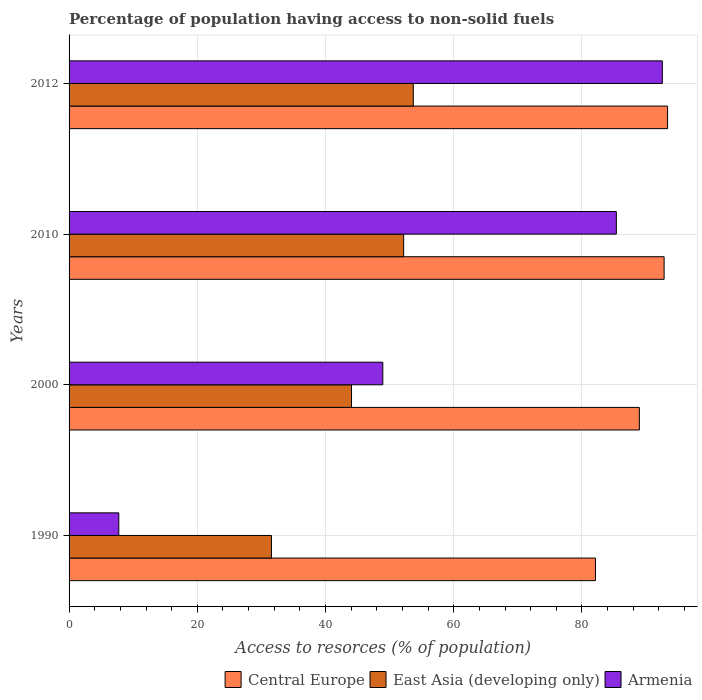Are the number of bars per tick equal to the number of legend labels?
Give a very brief answer. Yes. How many bars are there on the 1st tick from the top?
Your answer should be compact. 3. In how many cases, is the number of bars for a given year not equal to the number of legend labels?
Your answer should be very brief. 0. What is the percentage of population having access to non-solid fuels in Armenia in 1990?
Ensure brevity in your answer.  7.75. Across all years, what is the maximum percentage of population having access to non-solid fuels in Armenia?
Offer a terse response. 92.53. Across all years, what is the minimum percentage of population having access to non-solid fuels in East Asia (developing only)?
Provide a short and direct response. 31.57. What is the total percentage of population having access to non-solid fuels in Central Europe in the graph?
Offer a terse response. 357.22. What is the difference between the percentage of population having access to non-solid fuels in East Asia (developing only) in 1990 and that in 2012?
Make the answer very short. -22.12. What is the difference between the percentage of population having access to non-solid fuels in East Asia (developing only) in 1990 and the percentage of population having access to non-solid fuels in Central Europe in 2010?
Keep it short and to the point. -61.25. What is the average percentage of population having access to non-solid fuels in Armenia per year?
Provide a short and direct response. 58.65. In the year 1990, what is the difference between the percentage of population having access to non-solid fuels in East Asia (developing only) and percentage of population having access to non-solid fuels in Armenia?
Offer a terse response. 23.81. In how many years, is the percentage of population having access to non-solid fuels in East Asia (developing only) greater than 64 %?
Ensure brevity in your answer.  0. What is the ratio of the percentage of population having access to non-solid fuels in Central Europe in 1990 to that in 2012?
Ensure brevity in your answer.  0.88. What is the difference between the highest and the second highest percentage of population having access to non-solid fuels in East Asia (developing only)?
Offer a very short reply. 1.5. What is the difference between the highest and the lowest percentage of population having access to non-solid fuels in Armenia?
Your answer should be very brief. 84.78. In how many years, is the percentage of population having access to non-solid fuels in Central Europe greater than the average percentage of population having access to non-solid fuels in Central Europe taken over all years?
Give a very brief answer. 2. Is the sum of the percentage of population having access to non-solid fuels in Armenia in 2010 and 2012 greater than the maximum percentage of population having access to non-solid fuels in East Asia (developing only) across all years?
Provide a short and direct response. Yes. What does the 1st bar from the top in 2010 represents?
Provide a short and direct response. Armenia. What does the 3rd bar from the bottom in 2010 represents?
Keep it short and to the point. Armenia. Are all the bars in the graph horizontal?
Your answer should be compact. Yes. What is the difference between two consecutive major ticks on the X-axis?
Your answer should be compact. 20. Are the values on the major ticks of X-axis written in scientific E-notation?
Offer a very short reply. No. Does the graph contain any zero values?
Provide a short and direct response. No. Where does the legend appear in the graph?
Provide a short and direct response. Bottom right. How many legend labels are there?
Offer a very short reply. 3. How are the legend labels stacked?
Provide a succinct answer. Horizontal. What is the title of the graph?
Give a very brief answer. Percentage of population having access to non-solid fuels. What is the label or title of the X-axis?
Provide a succinct answer. Access to resorces (% of population). What is the Access to resorces (% of population) of Central Europe in 1990?
Keep it short and to the point. 82.1. What is the Access to resorces (% of population) in East Asia (developing only) in 1990?
Keep it short and to the point. 31.57. What is the Access to resorces (% of population) of Armenia in 1990?
Offer a very short reply. 7.75. What is the Access to resorces (% of population) in Central Europe in 2000?
Your response must be concise. 88.95. What is the Access to resorces (% of population) in East Asia (developing only) in 2000?
Ensure brevity in your answer.  44.05. What is the Access to resorces (% of population) in Armenia in 2000?
Give a very brief answer. 48.94. What is the Access to resorces (% of population) in Central Europe in 2010?
Keep it short and to the point. 92.81. What is the Access to resorces (% of population) in East Asia (developing only) in 2010?
Make the answer very short. 52.19. What is the Access to resorces (% of population) in Armenia in 2010?
Provide a short and direct response. 85.36. What is the Access to resorces (% of population) in Central Europe in 2012?
Offer a terse response. 93.35. What is the Access to resorces (% of population) in East Asia (developing only) in 2012?
Your answer should be very brief. 53.69. What is the Access to resorces (% of population) in Armenia in 2012?
Ensure brevity in your answer.  92.53. Across all years, what is the maximum Access to resorces (% of population) in Central Europe?
Give a very brief answer. 93.35. Across all years, what is the maximum Access to resorces (% of population) of East Asia (developing only)?
Provide a short and direct response. 53.69. Across all years, what is the maximum Access to resorces (% of population) in Armenia?
Your answer should be very brief. 92.53. Across all years, what is the minimum Access to resorces (% of population) of Central Europe?
Offer a terse response. 82.1. Across all years, what is the minimum Access to resorces (% of population) in East Asia (developing only)?
Offer a terse response. 31.57. Across all years, what is the minimum Access to resorces (% of population) in Armenia?
Your answer should be compact. 7.75. What is the total Access to resorces (% of population) of Central Europe in the graph?
Provide a succinct answer. 357.22. What is the total Access to resorces (% of population) in East Asia (developing only) in the graph?
Give a very brief answer. 181.5. What is the total Access to resorces (% of population) in Armenia in the graph?
Ensure brevity in your answer.  234.59. What is the difference between the Access to resorces (% of population) of Central Europe in 1990 and that in 2000?
Your answer should be very brief. -6.85. What is the difference between the Access to resorces (% of population) of East Asia (developing only) in 1990 and that in 2000?
Provide a short and direct response. -12.49. What is the difference between the Access to resorces (% of population) of Armenia in 1990 and that in 2000?
Your answer should be very brief. -41.18. What is the difference between the Access to resorces (% of population) of Central Europe in 1990 and that in 2010?
Keep it short and to the point. -10.71. What is the difference between the Access to resorces (% of population) in East Asia (developing only) in 1990 and that in 2010?
Offer a very short reply. -20.62. What is the difference between the Access to resorces (% of population) of Armenia in 1990 and that in 2010?
Your answer should be very brief. -77.61. What is the difference between the Access to resorces (% of population) of Central Europe in 1990 and that in 2012?
Your answer should be compact. -11.25. What is the difference between the Access to resorces (% of population) in East Asia (developing only) in 1990 and that in 2012?
Keep it short and to the point. -22.12. What is the difference between the Access to resorces (% of population) in Armenia in 1990 and that in 2012?
Keep it short and to the point. -84.78. What is the difference between the Access to resorces (% of population) in Central Europe in 2000 and that in 2010?
Your answer should be compact. -3.86. What is the difference between the Access to resorces (% of population) in East Asia (developing only) in 2000 and that in 2010?
Give a very brief answer. -8.14. What is the difference between the Access to resorces (% of population) in Armenia in 2000 and that in 2010?
Your answer should be very brief. -36.43. What is the difference between the Access to resorces (% of population) of Central Europe in 2000 and that in 2012?
Your response must be concise. -4.4. What is the difference between the Access to resorces (% of population) of East Asia (developing only) in 2000 and that in 2012?
Make the answer very short. -9.64. What is the difference between the Access to resorces (% of population) of Armenia in 2000 and that in 2012?
Your response must be concise. -43.6. What is the difference between the Access to resorces (% of population) in Central Europe in 2010 and that in 2012?
Ensure brevity in your answer.  -0.54. What is the difference between the Access to resorces (% of population) of East Asia (developing only) in 2010 and that in 2012?
Give a very brief answer. -1.5. What is the difference between the Access to resorces (% of population) of Armenia in 2010 and that in 2012?
Make the answer very short. -7.17. What is the difference between the Access to resorces (% of population) of Central Europe in 1990 and the Access to resorces (% of population) of East Asia (developing only) in 2000?
Give a very brief answer. 38.05. What is the difference between the Access to resorces (% of population) in Central Europe in 1990 and the Access to resorces (% of population) in Armenia in 2000?
Your response must be concise. 33.17. What is the difference between the Access to resorces (% of population) in East Asia (developing only) in 1990 and the Access to resorces (% of population) in Armenia in 2000?
Provide a succinct answer. -17.37. What is the difference between the Access to resorces (% of population) in Central Europe in 1990 and the Access to resorces (% of population) in East Asia (developing only) in 2010?
Provide a short and direct response. 29.91. What is the difference between the Access to resorces (% of population) of Central Europe in 1990 and the Access to resorces (% of population) of Armenia in 2010?
Make the answer very short. -3.26. What is the difference between the Access to resorces (% of population) in East Asia (developing only) in 1990 and the Access to resorces (% of population) in Armenia in 2010?
Keep it short and to the point. -53.79. What is the difference between the Access to resorces (% of population) in Central Europe in 1990 and the Access to resorces (% of population) in East Asia (developing only) in 2012?
Your answer should be compact. 28.41. What is the difference between the Access to resorces (% of population) of Central Europe in 1990 and the Access to resorces (% of population) of Armenia in 2012?
Offer a terse response. -10.43. What is the difference between the Access to resorces (% of population) of East Asia (developing only) in 1990 and the Access to resorces (% of population) of Armenia in 2012?
Keep it short and to the point. -60.97. What is the difference between the Access to resorces (% of population) of Central Europe in 2000 and the Access to resorces (% of population) of East Asia (developing only) in 2010?
Provide a succinct answer. 36.76. What is the difference between the Access to resorces (% of population) in Central Europe in 2000 and the Access to resorces (% of population) in Armenia in 2010?
Make the answer very short. 3.59. What is the difference between the Access to resorces (% of population) in East Asia (developing only) in 2000 and the Access to resorces (% of population) in Armenia in 2010?
Your answer should be compact. -41.31. What is the difference between the Access to resorces (% of population) of Central Europe in 2000 and the Access to resorces (% of population) of East Asia (developing only) in 2012?
Provide a short and direct response. 35.26. What is the difference between the Access to resorces (% of population) of Central Europe in 2000 and the Access to resorces (% of population) of Armenia in 2012?
Your answer should be very brief. -3.58. What is the difference between the Access to resorces (% of population) in East Asia (developing only) in 2000 and the Access to resorces (% of population) in Armenia in 2012?
Your answer should be very brief. -48.48. What is the difference between the Access to resorces (% of population) in Central Europe in 2010 and the Access to resorces (% of population) in East Asia (developing only) in 2012?
Ensure brevity in your answer.  39.12. What is the difference between the Access to resorces (% of population) of Central Europe in 2010 and the Access to resorces (% of population) of Armenia in 2012?
Your answer should be compact. 0.28. What is the difference between the Access to resorces (% of population) in East Asia (developing only) in 2010 and the Access to resorces (% of population) in Armenia in 2012?
Offer a very short reply. -40.34. What is the average Access to resorces (% of population) in Central Europe per year?
Give a very brief answer. 89.31. What is the average Access to resorces (% of population) of East Asia (developing only) per year?
Provide a succinct answer. 45.38. What is the average Access to resorces (% of population) in Armenia per year?
Keep it short and to the point. 58.65. In the year 1990, what is the difference between the Access to resorces (% of population) of Central Europe and Access to resorces (% of population) of East Asia (developing only)?
Your response must be concise. 50.54. In the year 1990, what is the difference between the Access to resorces (% of population) of Central Europe and Access to resorces (% of population) of Armenia?
Your response must be concise. 74.35. In the year 1990, what is the difference between the Access to resorces (% of population) of East Asia (developing only) and Access to resorces (% of population) of Armenia?
Your answer should be compact. 23.81. In the year 2000, what is the difference between the Access to resorces (% of population) of Central Europe and Access to resorces (% of population) of East Asia (developing only)?
Your answer should be very brief. 44.9. In the year 2000, what is the difference between the Access to resorces (% of population) of Central Europe and Access to resorces (% of population) of Armenia?
Your answer should be compact. 40.02. In the year 2000, what is the difference between the Access to resorces (% of population) of East Asia (developing only) and Access to resorces (% of population) of Armenia?
Provide a short and direct response. -4.88. In the year 2010, what is the difference between the Access to resorces (% of population) of Central Europe and Access to resorces (% of population) of East Asia (developing only)?
Make the answer very short. 40.62. In the year 2010, what is the difference between the Access to resorces (% of population) in Central Europe and Access to resorces (% of population) in Armenia?
Give a very brief answer. 7.45. In the year 2010, what is the difference between the Access to resorces (% of population) in East Asia (developing only) and Access to resorces (% of population) in Armenia?
Your answer should be compact. -33.17. In the year 2012, what is the difference between the Access to resorces (% of population) in Central Europe and Access to resorces (% of population) in East Asia (developing only)?
Provide a succinct answer. 39.66. In the year 2012, what is the difference between the Access to resorces (% of population) of Central Europe and Access to resorces (% of population) of Armenia?
Provide a succinct answer. 0.82. In the year 2012, what is the difference between the Access to resorces (% of population) of East Asia (developing only) and Access to resorces (% of population) of Armenia?
Ensure brevity in your answer.  -38.84. What is the ratio of the Access to resorces (% of population) of Central Europe in 1990 to that in 2000?
Provide a short and direct response. 0.92. What is the ratio of the Access to resorces (% of population) in East Asia (developing only) in 1990 to that in 2000?
Your answer should be very brief. 0.72. What is the ratio of the Access to resorces (% of population) in Armenia in 1990 to that in 2000?
Your answer should be compact. 0.16. What is the ratio of the Access to resorces (% of population) in Central Europe in 1990 to that in 2010?
Your response must be concise. 0.88. What is the ratio of the Access to resorces (% of population) in East Asia (developing only) in 1990 to that in 2010?
Keep it short and to the point. 0.6. What is the ratio of the Access to resorces (% of population) of Armenia in 1990 to that in 2010?
Make the answer very short. 0.09. What is the ratio of the Access to resorces (% of population) in Central Europe in 1990 to that in 2012?
Offer a very short reply. 0.88. What is the ratio of the Access to resorces (% of population) of East Asia (developing only) in 1990 to that in 2012?
Offer a very short reply. 0.59. What is the ratio of the Access to resorces (% of population) in Armenia in 1990 to that in 2012?
Give a very brief answer. 0.08. What is the ratio of the Access to resorces (% of population) in Central Europe in 2000 to that in 2010?
Give a very brief answer. 0.96. What is the ratio of the Access to resorces (% of population) of East Asia (developing only) in 2000 to that in 2010?
Make the answer very short. 0.84. What is the ratio of the Access to resorces (% of population) of Armenia in 2000 to that in 2010?
Keep it short and to the point. 0.57. What is the ratio of the Access to resorces (% of population) in Central Europe in 2000 to that in 2012?
Ensure brevity in your answer.  0.95. What is the ratio of the Access to resorces (% of population) of East Asia (developing only) in 2000 to that in 2012?
Your answer should be compact. 0.82. What is the ratio of the Access to resorces (% of population) in Armenia in 2000 to that in 2012?
Make the answer very short. 0.53. What is the ratio of the Access to resorces (% of population) in Central Europe in 2010 to that in 2012?
Ensure brevity in your answer.  0.99. What is the ratio of the Access to resorces (% of population) of East Asia (developing only) in 2010 to that in 2012?
Keep it short and to the point. 0.97. What is the ratio of the Access to resorces (% of population) in Armenia in 2010 to that in 2012?
Keep it short and to the point. 0.92. What is the difference between the highest and the second highest Access to resorces (% of population) in Central Europe?
Provide a succinct answer. 0.54. What is the difference between the highest and the second highest Access to resorces (% of population) in East Asia (developing only)?
Make the answer very short. 1.5. What is the difference between the highest and the second highest Access to resorces (% of population) of Armenia?
Your answer should be compact. 7.17. What is the difference between the highest and the lowest Access to resorces (% of population) of Central Europe?
Your response must be concise. 11.25. What is the difference between the highest and the lowest Access to resorces (% of population) of East Asia (developing only)?
Offer a terse response. 22.12. What is the difference between the highest and the lowest Access to resorces (% of population) in Armenia?
Provide a short and direct response. 84.78. 